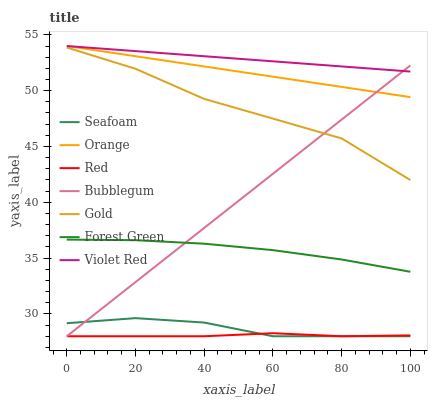Does Red have the minimum area under the curve?
Answer yes or no. Yes. Does Violet Red have the maximum area under the curve?
Answer yes or no. Yes. Does Gold have the minimum area under the curve?
Answer yes or no. No. Does Gold have the maximum area under the curve?
Answer yes or no. No. Is Violet Red the smoothest?
Answer yes or no. Yes. Is Gold the roughest?
Answer yes or no. Yes. Is Seafoam the smoothest?
Answer yes or no. No. Is Seafoam the roughest?
Answer yes or no. No. Does Gold have the lowest value?
Answer yes or no. No. Does Orange have the highest value?
Answer yes or no. Yes. Does Gold have the highest value?
Answer yes or no. No. Is Forest Green less than Gold?
Answer yes or no. Yes. Is Violet Red greater than Forest Green?
Answer yes or no. Yes. Does Forest Green intersect Gold?
Answer yes or no. No. 